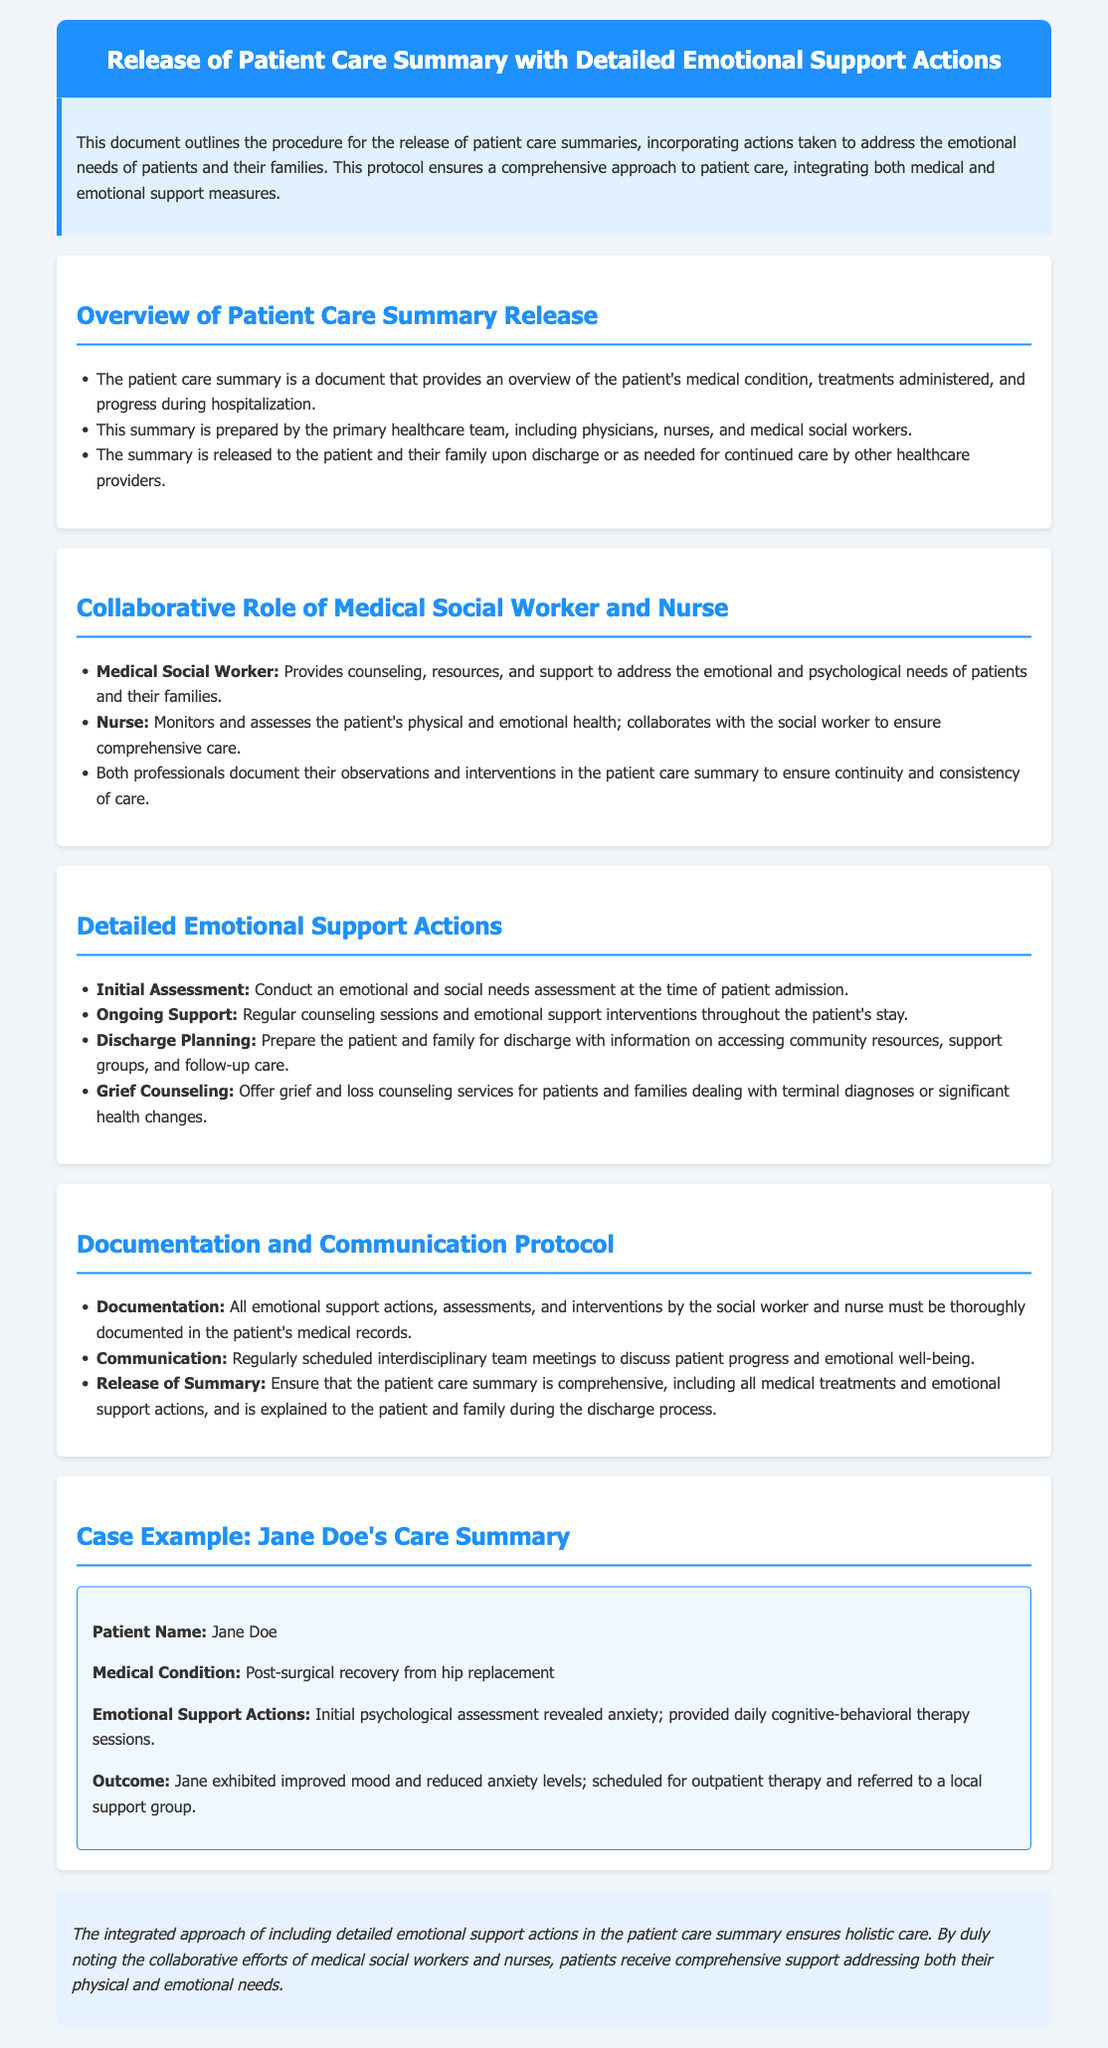What is the title of the document? The title of the document is provided in the header section, indicating the focus on releasing patient care summaries with emotional support actions.
Answer: Release of Patient Care Summary with Detailed Emotional Support Actions What does the patient care summary provide? The document states that the patient care summary provides an overview of the patient's medical condition, treatments administered, and progress during hospitalization.
Answer: Overview of the patient's medical condition Who prepares the patient care summary? The document mentions that the summary is prepared by the primary healthcare team, including physicians, nurses, and medical social workers.
Answer: Primary healthcare team What role does the medical social worker have? According to the document, the medical social worker provides counseling, resources, and support to address the emotional and psychological needs of patients and their families.
Answer: Provides counseling and support What is one type of emotional support action mentioned? The document lists various emotional support actions, including conducting an emotional and social needs assessment at the time of patient admission.
Answer: Initial Assessment What is the purpose of interdisciplinary team meetings? The document specifies that these meetings are scheduled to discuss patient progress and emotional well-being, emphasizing their role in collaboration.
Answer: Discuss patient progress What is documented in the patient care summary? The document states that all emotional support actions, assessments, and interventions by the social worker and nurse must be documented in the patient's medical records.
Answer: Emotional support actions What was Jane Doe's medical condition? The specific medical condition of the patient Jane Doe is referenced as part of the case example in the document.
Answer: Post-surgical recovery from hip replacement What is the outcome for Jane Doe? The case example explains that Jane exhibited improved mood and reduced anxiety levels, leading to further steps in her care.
Answer: Improved mood and reduced anxiety levels What does the conclusion emphasize? The conclusion highlights the importance of an integrated approach in patient care, underscoring the benefits of addressing both physical and emotional needs.
Answer: Holistic care 